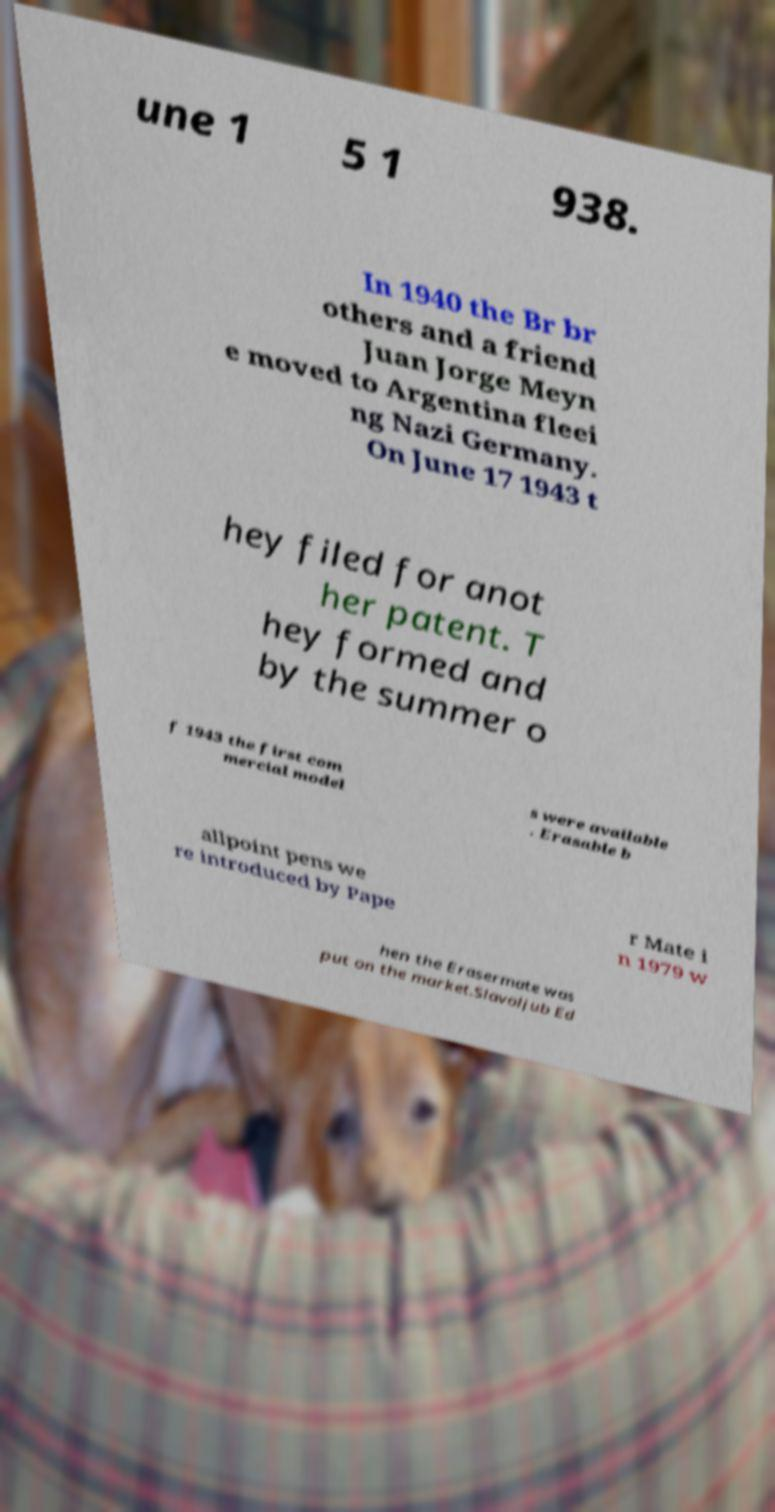Please identify and transcribe the text found in this image. une 1 5 1 938. In 1940 the Br br others and a friend Juan Jorge Meyn e moved to Argentina fleei ng Nazi Germany. On June 17 1943 t hey filed for anot her patent. T hey formed and by the summer o f 1943 the first com mercial model s were available . Erasable b allpoint pens we re introduced by Pape r Mate i n 1979 w hen the Erasermate was put on the market.Slavoljub Ed 